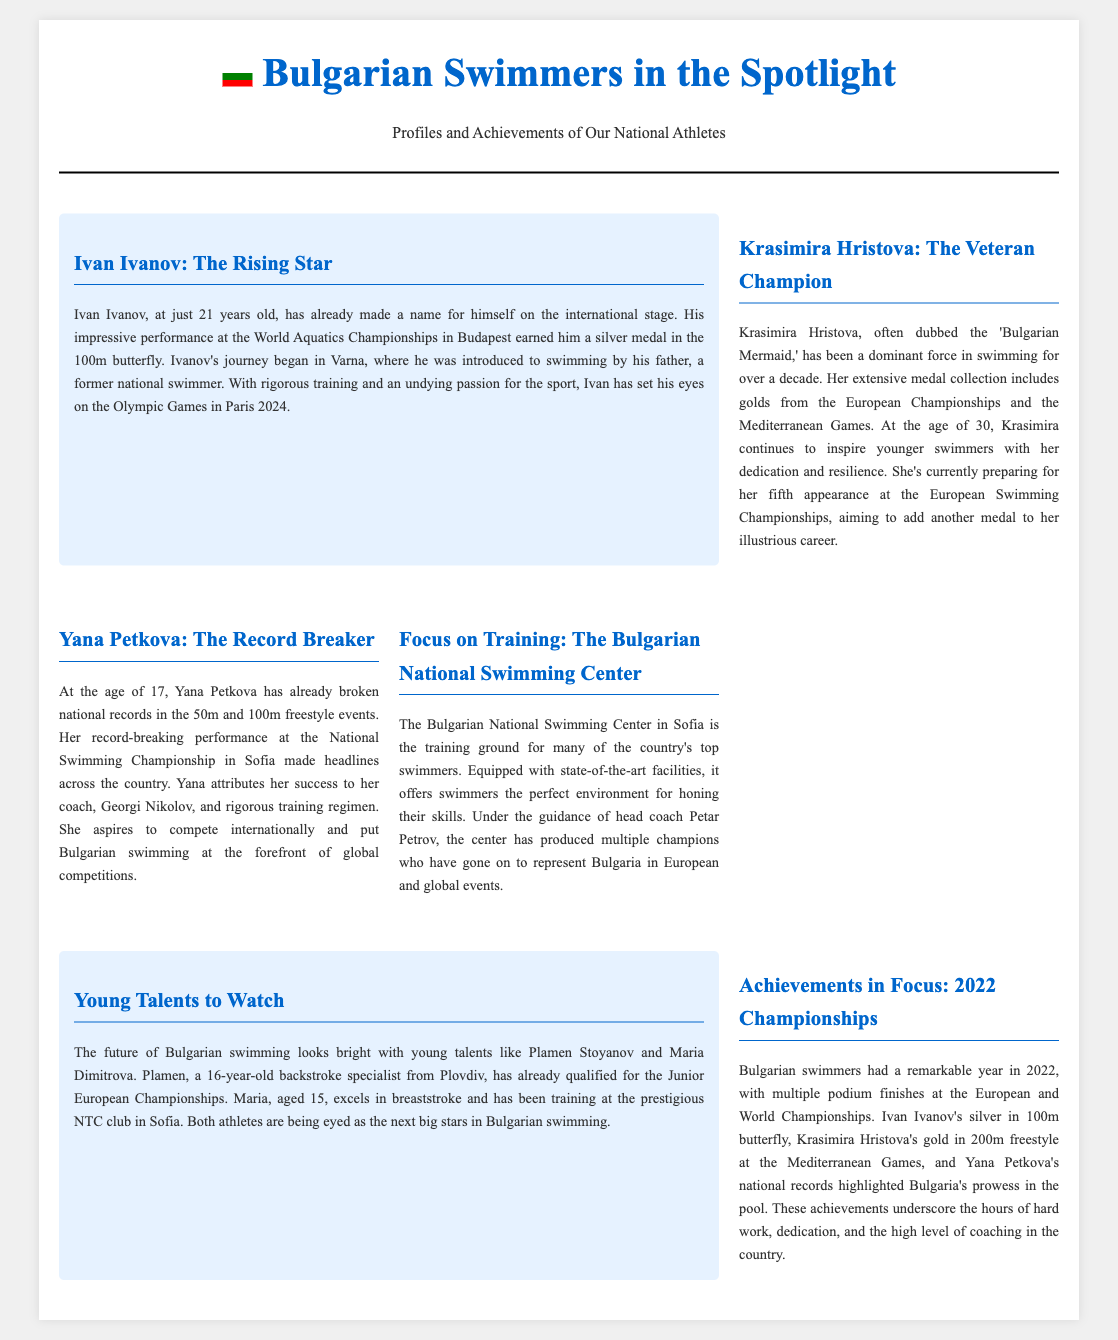What is Ivan Ivanov's age? The document states that Ivan Ivanov is 21 years old.
Answer: 21 Which medal did Ivan Ivanov earn at the World Aquatics Championships? The document mentions that he earned a silver medal in the 100m butterfly.
Answer: Silver Who is referred to as the 'Bulgarian Mermaid'? The document identifies Krasimira Hristova with this nickname.
Answer: Krasimira Hristova What year did Yana Petkova break national records? The document indicates that Yana Petkova broke records at the National Swimming Championship in Sofia, but does not specify the year.
Answer: Not specified What is the focus of the training at the Bulgarian National Swimming Center? The document describes that the center is intended for honing the skills of top swimmers in Bulgaria.
Answer: Honing skills How old is Maria Dimitrova? The document states that Maria Dimitrova is 15 years old.
Answer: 15 What achievement did Krasimira Hristova earn in the Mediterranean Games? The document mentions she won a gold in the 200m freestyle.
Answer: Gold in 200m freestyle What is the main goal of young talents like Plamen Stoyanov? The document states that they are being eyed as the next big stars in Bulgarian swimming.
Answer: Next big stars How many appearances is Krasimira Hristova preparing for at the European Championships? The document mentions she is preparing for her fifth appearance.
Answer: Fifth appearance 